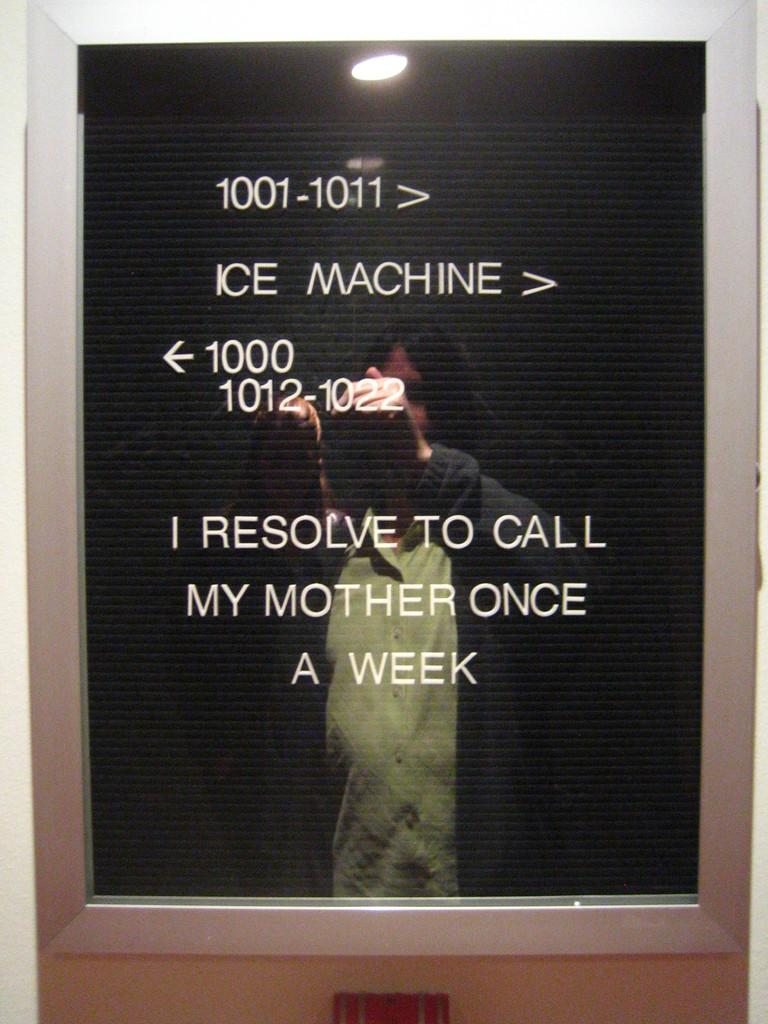<image>
Write a terse but informative summary of the picture. Advice about calling home once a week is displayed on a letter board below the directions to the ice machine. 